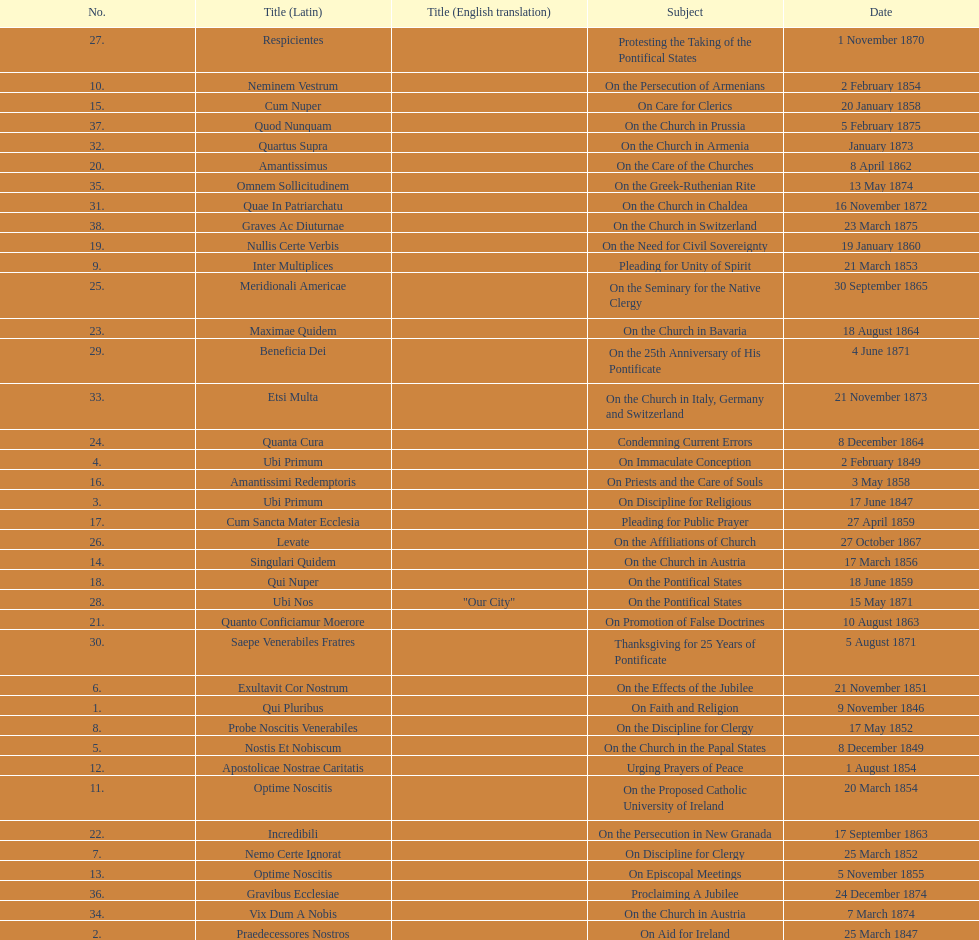Complete sum of encyclicals about churches. 11. 